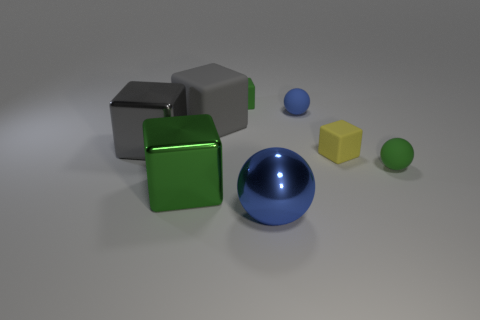Subtract all tiny blue matte balls. How many balls are left? 2 Add 1 big gray metallic cubes. How many objects exist? 9 Subtract all blue spheres. How many spheres are left? 1 Subtract all cubes. How many objects are left? 3 Subtract 2 balls. How many balls are left? 1 Subtract all cyan balls. Subtract all cyan cylinders. How many balls are left? 3 Subtract all green cylinders. How many blue blocks are left? 0 Subtract all green matte cubes. Subtract all tiny red matte things. How many objects are left? 7 Add 6 gray cubes. How many gray cubes are left? 8 Add 7 large rubber blocks. How many large rubber blocks exist? 8 